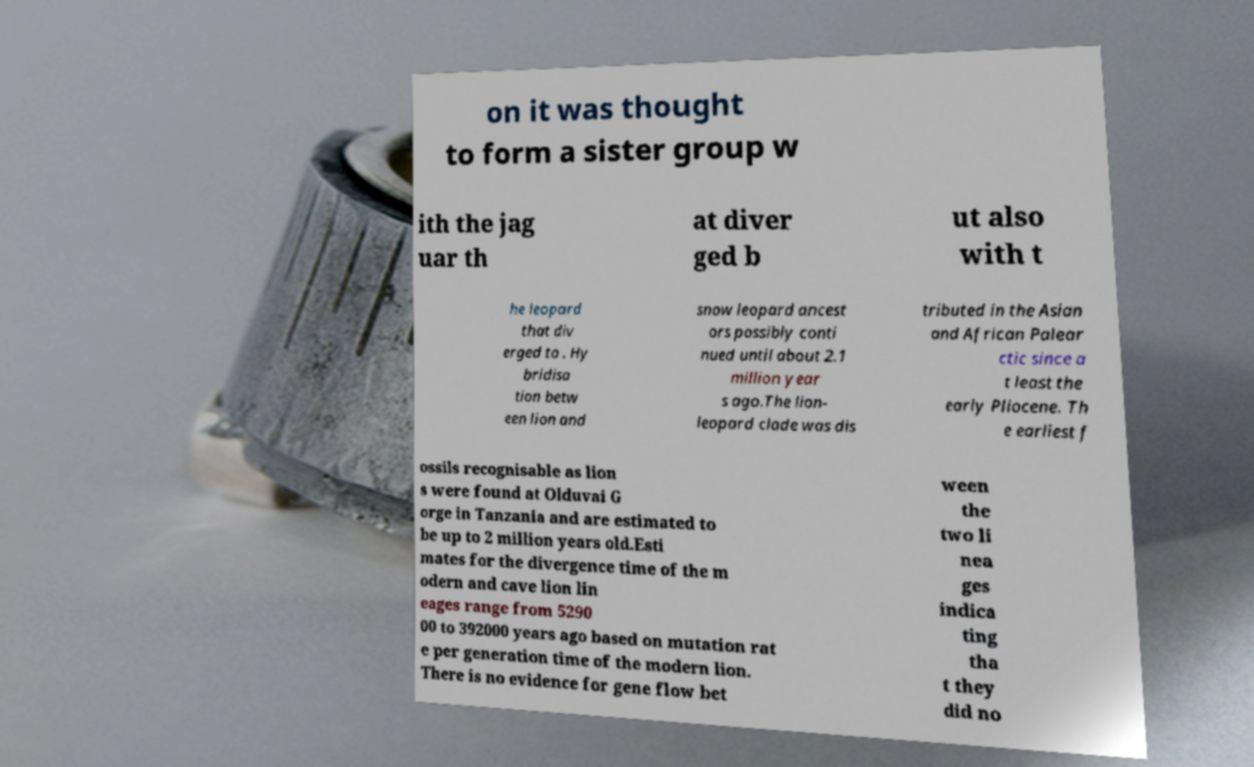Could you extract and type out the text from this image? on it was thought to form a sister group w ith the jag uar th at diver ged b ut also with t he leopard that div erged to . Hy bridisa tion betw een lion and snow leopard ancest ors possibly conti nued until about 2.1 million year s ago.The lion- leopard clade was dis tributed in the Asian and African Palear ctic since a t least the early Pliocene. Th e earliest f ossils recognisable as lion s were found at Olduvai G orge in Tanzania and are estimated to be up to 2 million years old.Esti mates for the divergence time of the m odern and cave lion lin eages range from 5290 00 to 392000 years ago based on mutation rat e per generation time of the modern lion. There is no evidence for gene flow bet ween the two li nea ges indica ting tha t they did no 